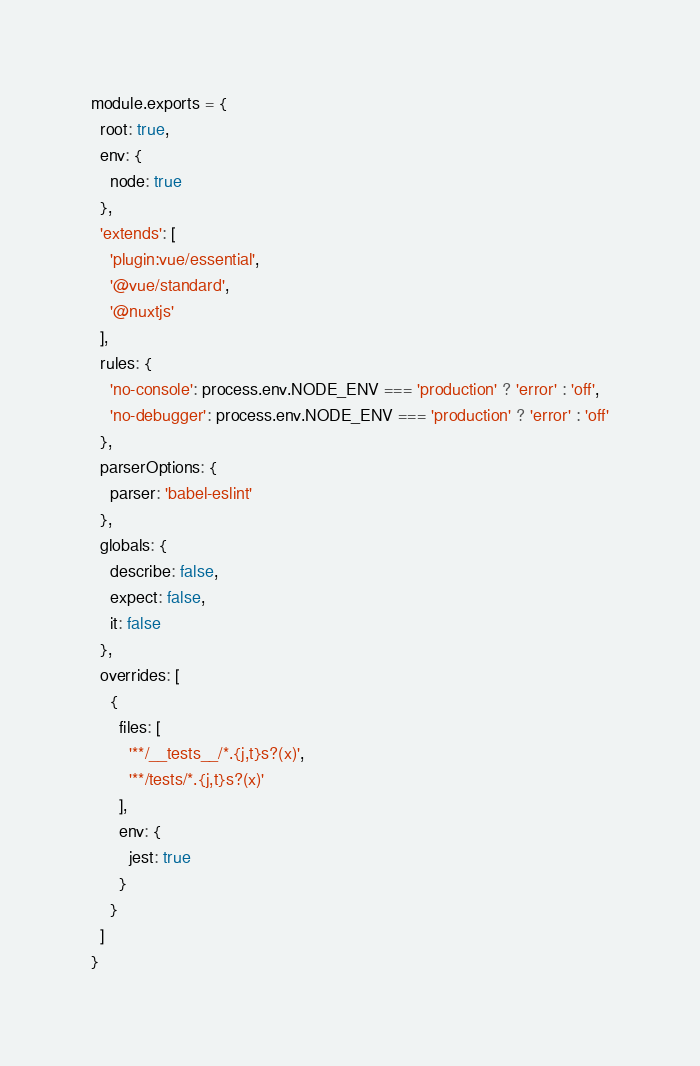<code> <loc_0><loc_0><loc_500><loc_500><_JavaScript_>module.exports = {
  root: true,
  env: {
    node: true
  },
  'extends': [
    'plugin:vue/essential',
    '@vue/standard',
    '@nuxtjs'
  ],
  rules: {
    'no-console': process.env.NODE_ENV === 'production' ? 'error' : 'off',
    'no-debugger': process.env.NODE_ENV === 'production' ? 'error' : 'off'
  },
  parserOptions: {
    parser: 'babel-eslint'
  },
  globals: {
    describe: false,
    expect: false,
    it: false
  },
  overrides: [
    {
      files: [
        '**/__tests__/*.{j,t}s?(x)',
        '**/tests/*.{j,t}s?(x)'
      ],
      env: {
        jest: true
      }
    }
  ]
}
</code> 